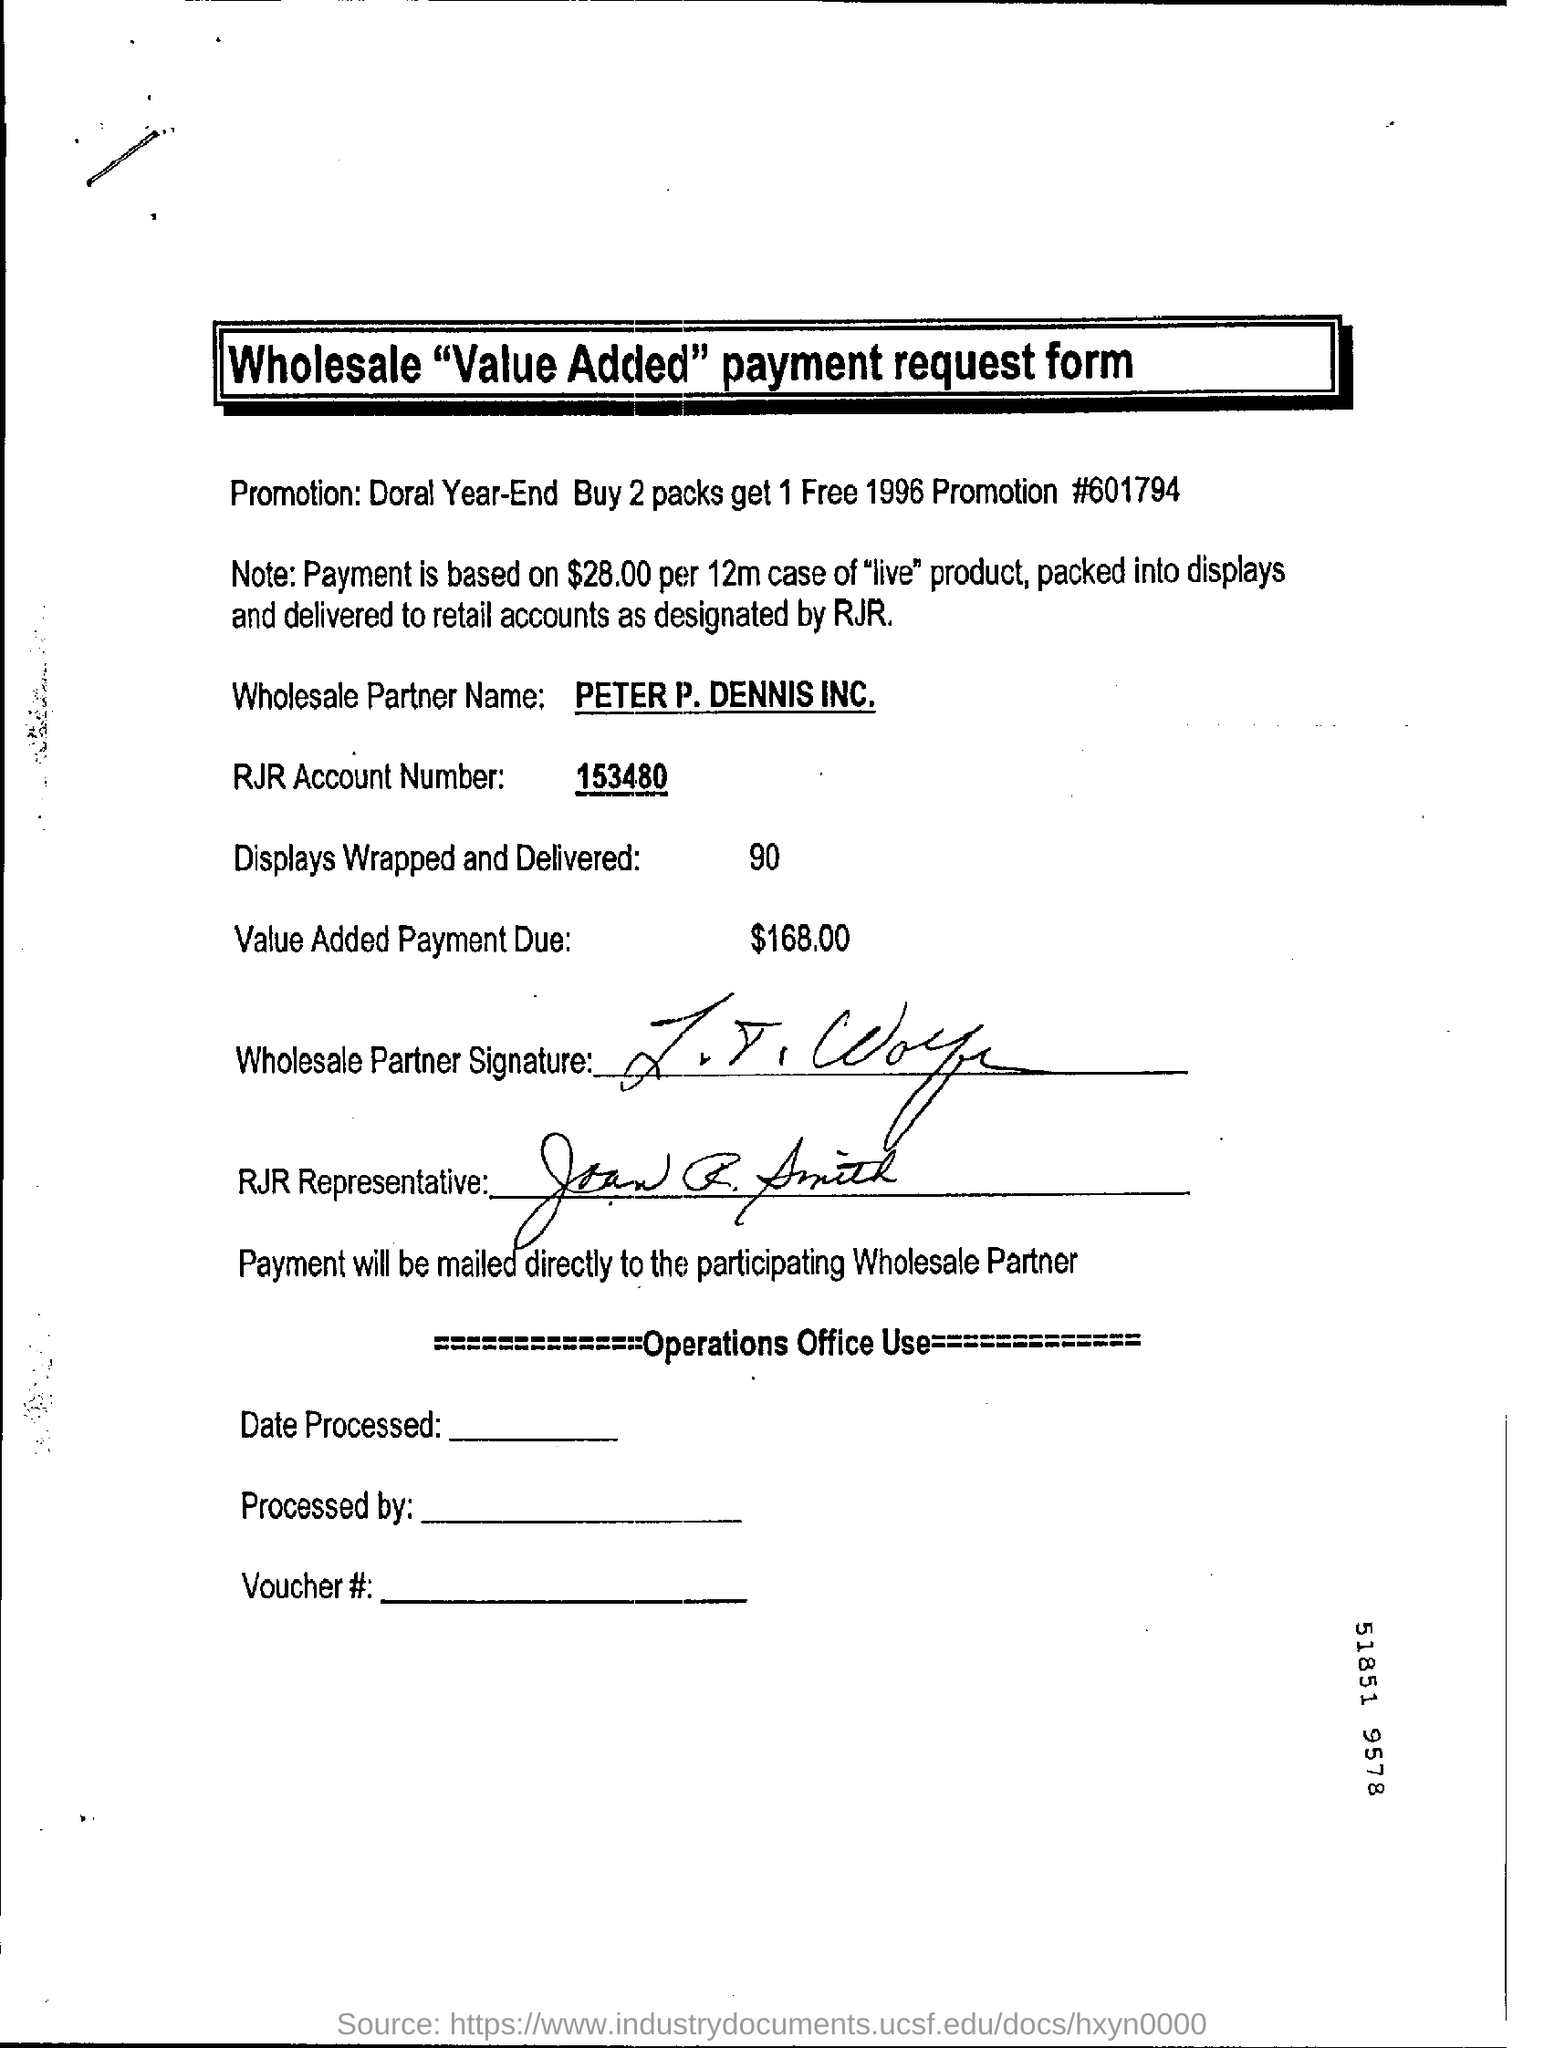What is the Wholesale Partner Name?
Your answer should be very brief. PETER P. DENNIS INC. What is the RJR Account Number?
Keep it short and to the point. 153480. 